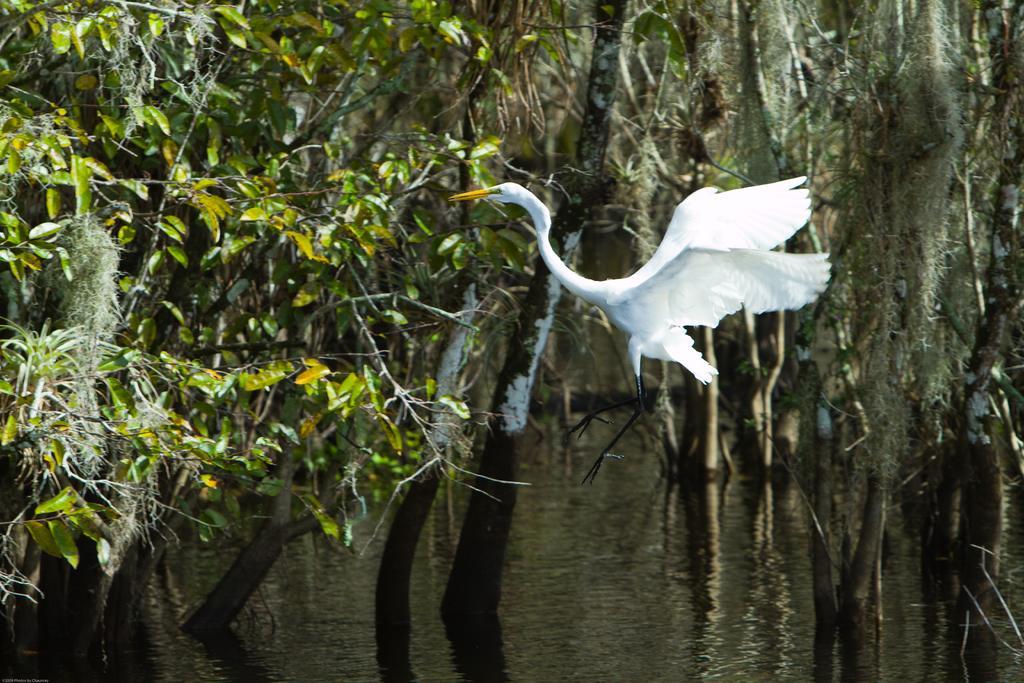In one or two sentences, can you explain what this image depicts? In this picture we can see a bird flying. In the background we can see leaves and branches. At the bottom portion of the picture we can see water. 